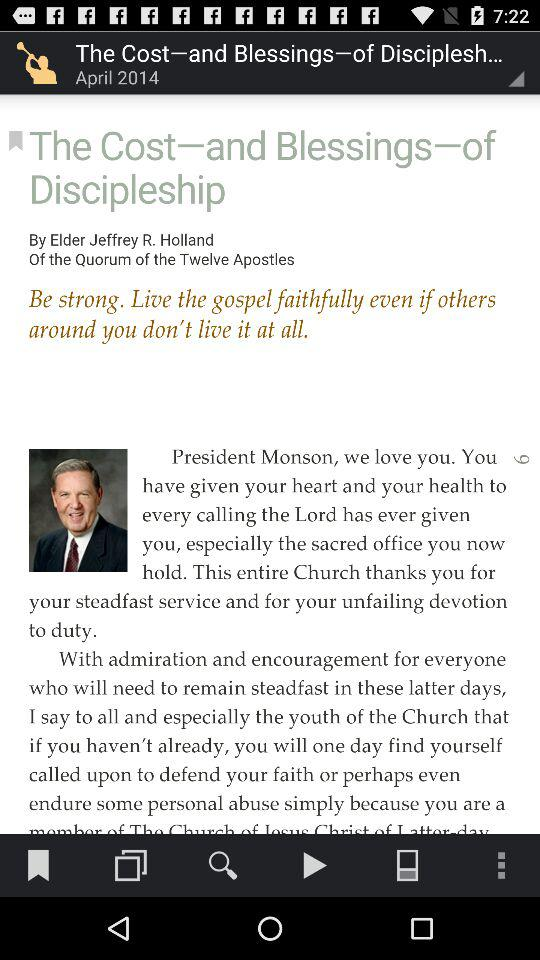Who is the author? The author is Elder Jeffrey R. Holland. 